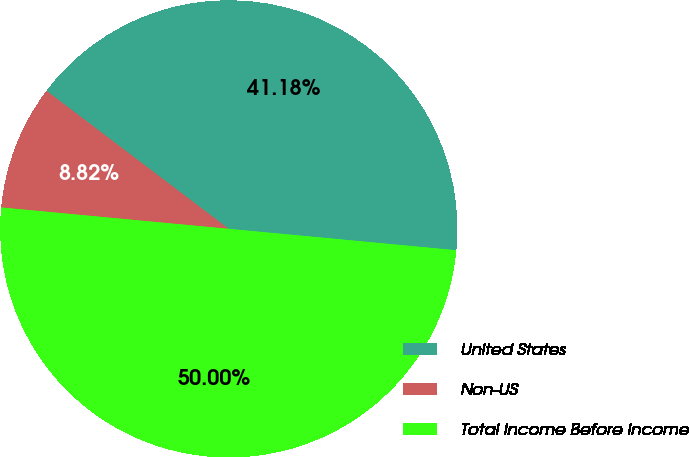Convert chart to OTSL. <chart><loc_0><loc_0><loc_500><loc_500><pie_chart><fcel>United States<fcel>Non-US<fcel>Total Income Before Income<nl><fcel>41.18%<fcel>8.82%<fcel>50.0%<nl></chart> 